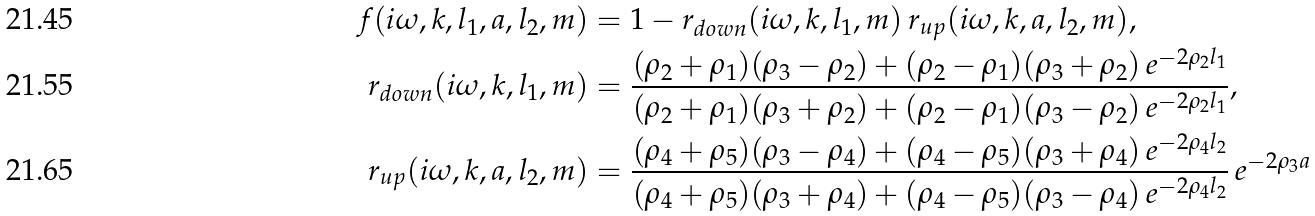Convert formula to latex. <formula><loc_0><loc_0><loc_500><loc_500>f ( i \omega , k , l _ { 1 } , a , l _ { 2 } , m ) & = 1 - r _ { d o w n } ( i \omega , k , l _ { 1 } , m ) \, r _ { u p } ( i \omega , k , a , l _ { 2 } , m ) , \\ r _ { d o w n } ( i \omega , k , l _ { 1 } , m ) & = \frac { ( \rho _ { 2 } + \rho _ { 1 } ) ( \rho _ { 3 } - \rho _ { 2 } ) + ( \rho _ { 2 } - \rho _ { 1 } ) ( \rho _ { 3 } + \rho _ { 2 } ) \, e ^ { - 2 \rho _ { 2 } l _ { 1 } } } { ( \rho _ { 2 } + \rho _ { 1 } ) ( \rho _ { 3 } + \rho _ { 2 } ) + ( \rho _ { 2 } - \rho _ { 1 } ) ( \rho _ { 3 } - \rho _ { 2 } ) \, e ^ { - 2 \rho _ { 2 } l _ { 1 } } } , \\ r _ { u p } ( i \omega , k , a , l _ { 2 } , m ) & = \frac { ( \rho _ { 4 } + \rho _ { 5 } ) ( \rho _ { 3 } - \rho _ { 4 } ) + ( \rho _ { 4 } - \rho _ { 5 } ) ( \rho _ { 3 } + \rho _ { 4 } ) \, e ^ { - 2 \rho _ { 4 } l _ { 2 } } } { ( \rho _ { 4 } + \rho _ { 5 } ) ( \rho _ { 3 } + \rho _ { 4 } ) + ( \rho _ { 4 } - \rho _ { 5 } ) ( \rho _ { 3 } - \rho _ { 4 } ) \, e ^ { - 2 \rho _ { 4 } l _ { 2 } } } \, e ^ { - 2 \rho _ { 3 } a }</formula> 